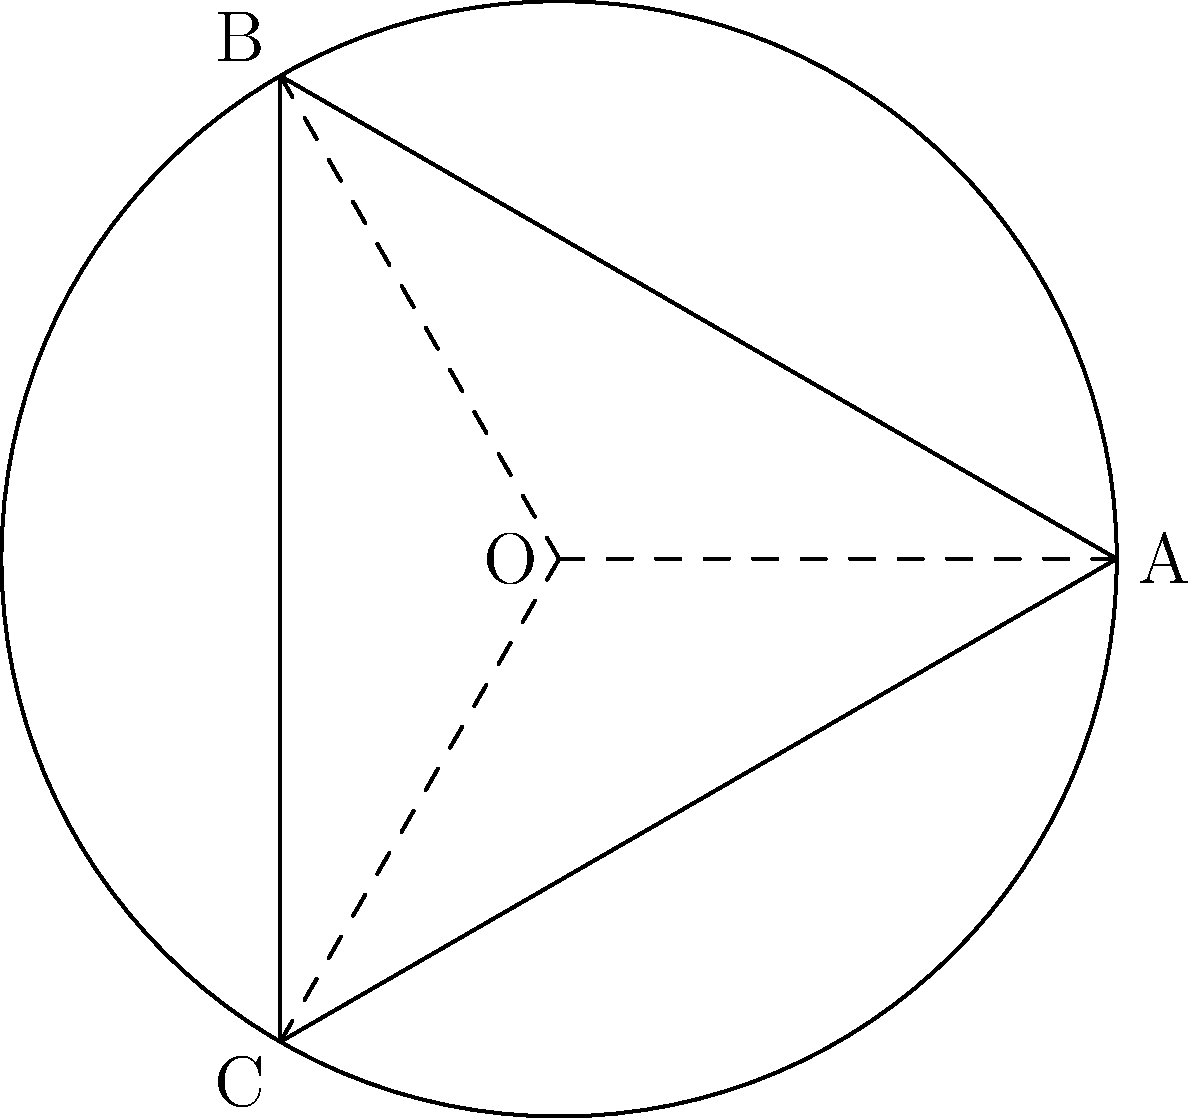In early science fiction films, set designers often struggled to represent non-Euclidean geometry on flat surfaces. Consider the triangle ABC drawn on the surface of a sphere, as shown in the diagram. If the sum of the interior angles of this spherical triangle is 270°, how does this relate to the curvature of the spherical surface, and how might this concept have been used in early sci-fi film set designs to create the illusion of curved space? To understand how this relates to early sci-fi film set designs and the curvature of space, let's break it down step-by-step:

1. In Euclidean geometry, the sum of the interior angles of a triangle is always 180°. However, on a spherical surface, this sum is always greater than 180°.

2. The excess angle (difference between the sum of interior angles and 180°) is directly proportional to the area of the spherical triangle and the curvature of the sphere.

3. In this case, the excess angle is 270° - 180° = 90°.

4. This excess indicates positive curvature, which is characteristic of spherical geometry.

5. The relationship between the excess angle (E), the area of the triangle (A), and the radius of the sphere (R) is given by the formula:

   $$E = \frac{A}{R^2}$$

6. Early sci-fi film set designers could use this concept to create the illusion of curved space by:
   a) Designing sets with triangular elements where the sum of angles is noticeably greater than 180°.
   b) Using forced perspective and curved set pieces to mimic the properties of spherical geometry.
   c) Employing painted backdrops with distorted geometric shapes to suggest non-Euclidean space.

7. By incorporating these visual cues, designers could make flat sets appear to exist on a curved surface, enhancing the otherworldly feel of alien planets or distorted spacetime in sci-fi films.

8. This approach would have been particularly effective in early black and white films, where subtle visual distortions could create a sense of unease or otherworldliness without the need for complex special effects.
Answer: Positive curvature; exaggerated angles and forced perspective in set design 